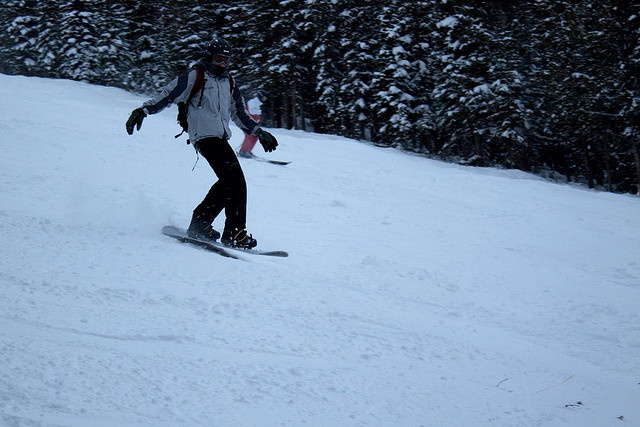Describe the objects in this image and their specific colors. I can see people in black, gray, and lightblue tones, snowboard in black, lightblue, gray, and blue tones, people in black, purple, and darkgray tones, and backpack in black, navy, gray, and blue tones in this image. 